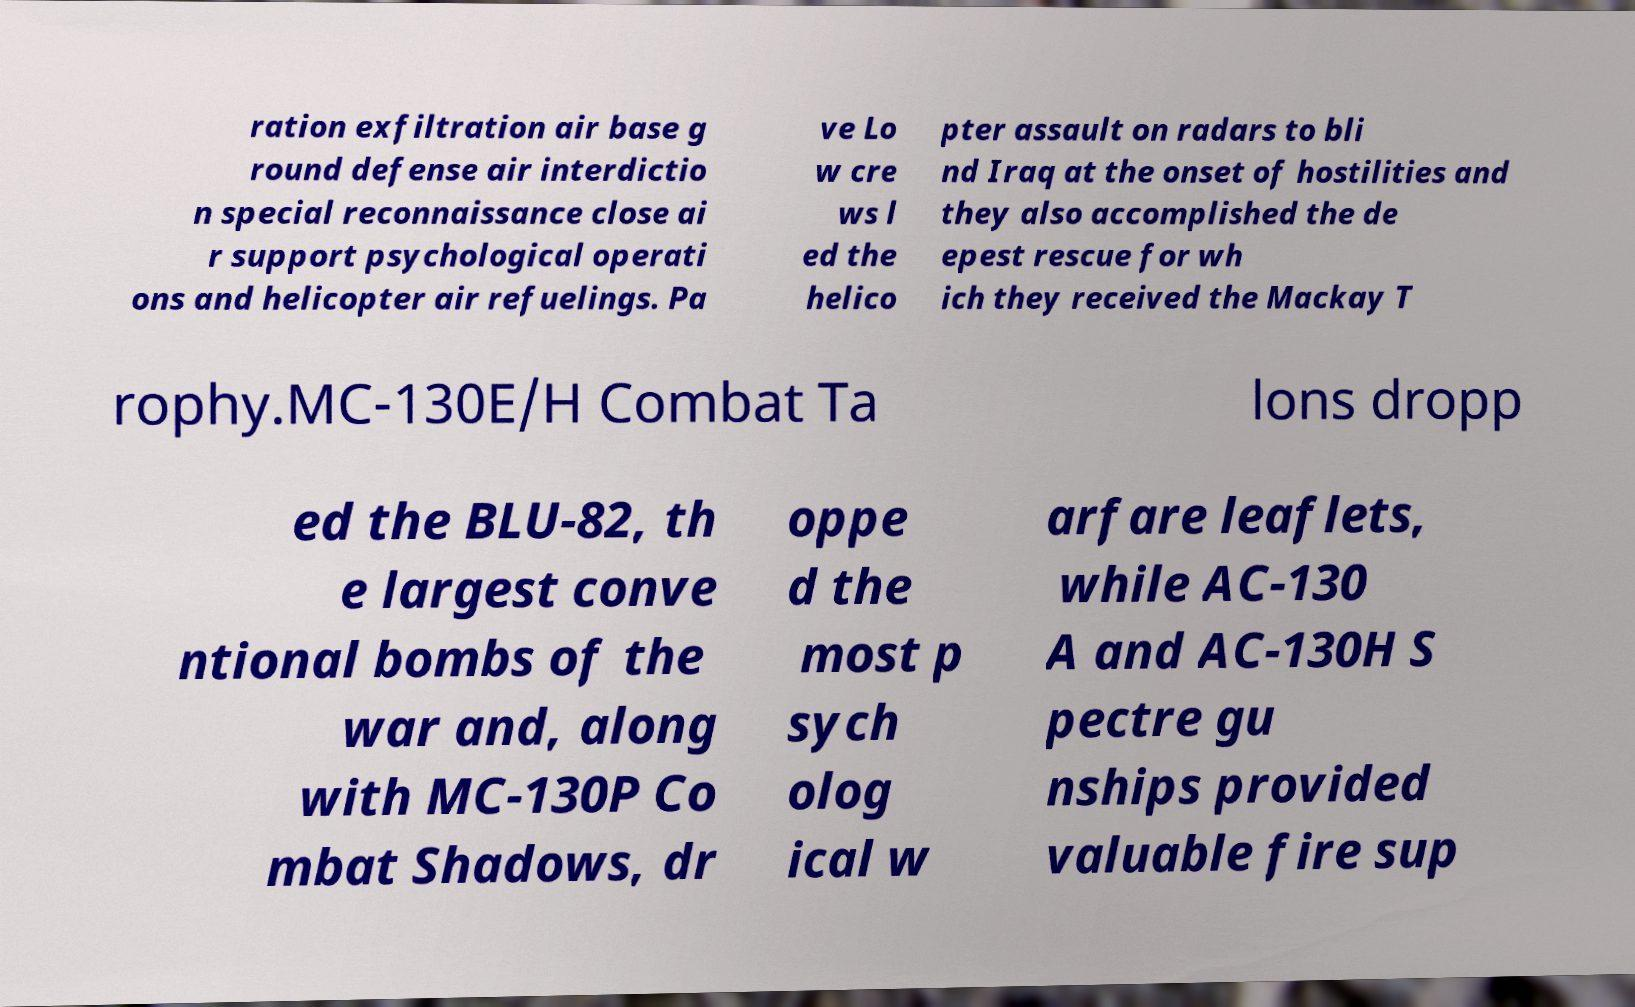What messages or text are displayed in this image? I need them in a readable, typed format. ration exfiltration air base g round defense air interdictio n special reconnaissance close ai r support psychological operati ons and helicopter air refuelings. Pa ve Lo w cre ws l ed the helico pter assault on radars to bli nd Iraq at the onset of hostilities and they also accomplished the de epest rescue for wh ich they received the Mackay T rophy.MC-130E/H Combat Ta lons dropp ed the BLU-82, th e largest conve ntional bombs of the war and, along with MC-130P Co mbat Shadows, dr oppe d the most p sych olog ical w arfare leaflets, while AC-130 A and AC-130H S pectre gu nships provided valuable fire sup 